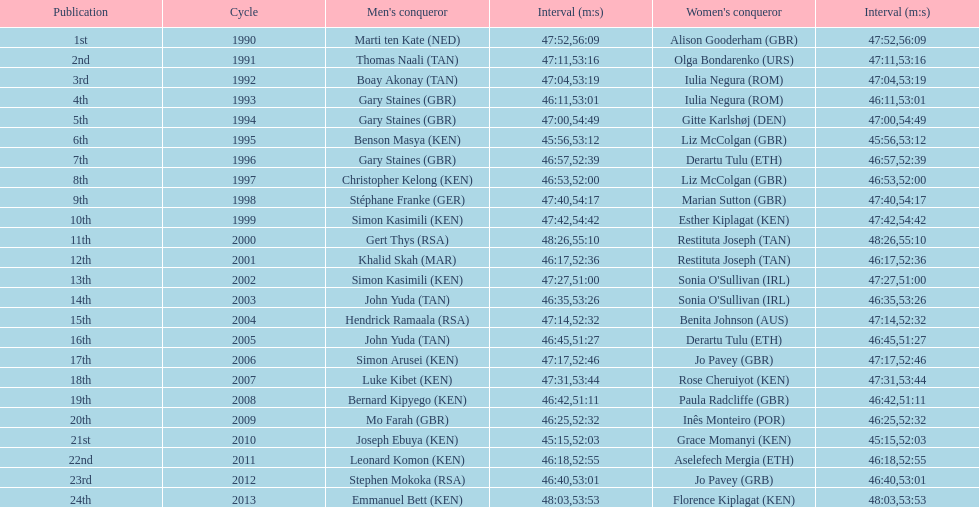The other women's winner with the same finish time as jo pavey in 2012 Iulia Negura. 